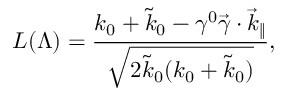Convert formula to latex. <formula><loc_0><loc_0><loc_500><loc_500>L ( \Lambda ) = \frac { k _ { 0 } + \tilde { k } _ { 0 } - \gamma ^ { 0 } \vec { \gamma } \cdot \vec { k } _ { \| } } { \sqrt { 2 \tilde { k } _ { 0 } ( k _ { 0 } + \tilde { k } _ { 0 } ) } } ,</formula> 